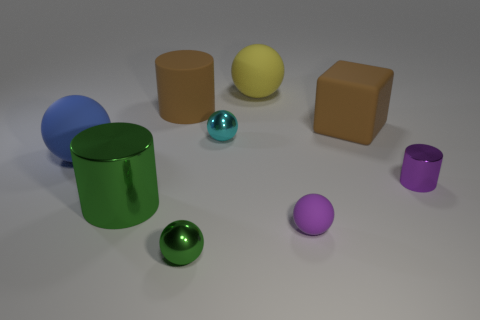Subtract all large blue spheres. How many spheres are left? 4 Subtract all cyan spheres. How many spheres are left? 4 Subtract all red spheres. Subtract all green cylinders. How many spheres are left? 5 Add 1 big yellow metal cylinders. How many objects exist? 10 Subtract all spheres. How many objects are left? 4 Add 5 yellow rubber balls. How many yellow rubber balls exist? 6 Subtract 0 gray cubes. How many objects are left? 9 Subtract all big objects. Subtract all large gray matte cylinders. How many objects are left? 4 Add 7 brown blocks. How many brown blocks are left? 8 